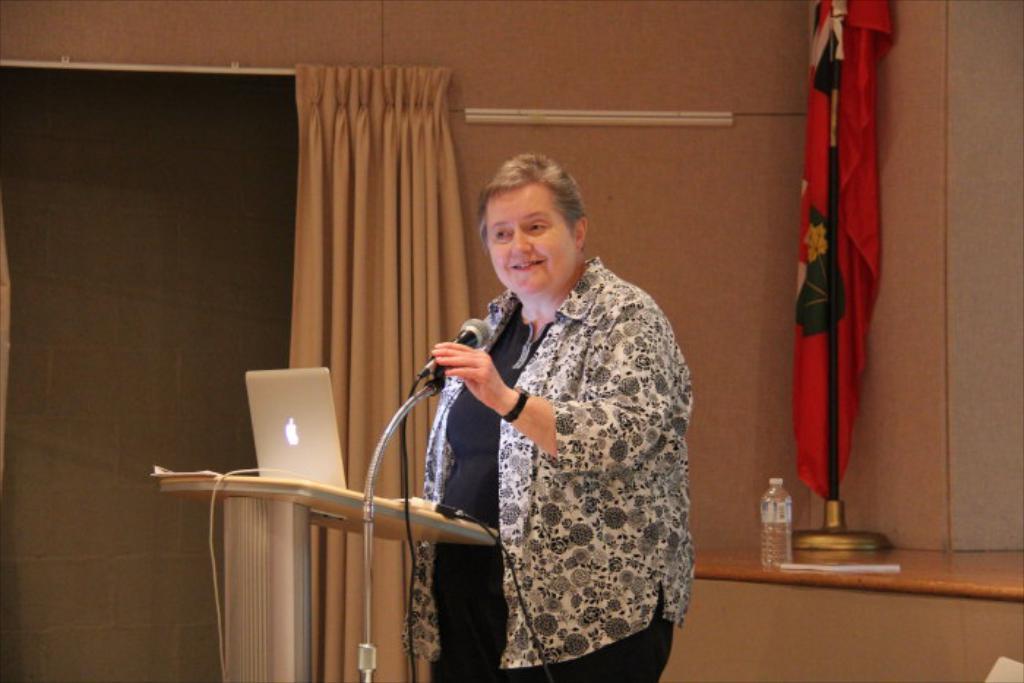Describe this image in one or two sentences. In this image in the center there is one woman standing, and she is holding a mike and in front of her there is one podium. On the podium there is a laptop and some wires, and in the background there is a board curtain, bottle and some papers and wall. 